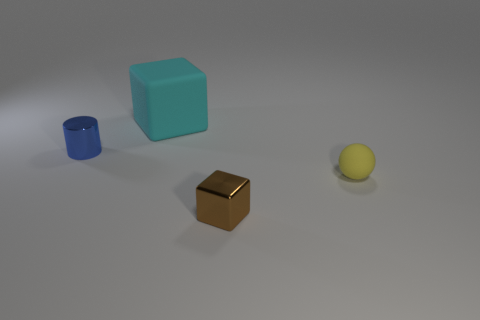How many things are large cyan cubes or red matte spheres?
Provide a succinct answer. 1. There is a block that is the same size as the cylinder; what is its color?
Keep it short and to the point. Brown. There is a brown metal object; is its shape the same as the metal thing left of the brown metallic object?
Provide a succinct answer. No. How many things are either objects behind the tiny yellow sphere or metallic things behind the yellow sphere?
Ensure brevity in your answer.  2. There is a small thing that is behind the tiny yellow thing; what shape is it?
Offer a very short reply. Cylinder. There is a tiny shiny object that is on the right side of the blue metallic cylinder; does it have the same shape as the cyan object?
Make the answer very short. Yes. How many things are either metal things that are in front of the small yellow ball or tiny blue balls?
Offer a very short reply. 1. What color is the big rubber object that is the same shape as the small brown metallic object?
Keep it short and to the point. Cyan. Are there any other things of the same color as the tiny metallic cylinder?
Your answer should be compact. No. There is a cube in front of the yellow matte thing; how big is it?
Provide a succinct answer. Small. 